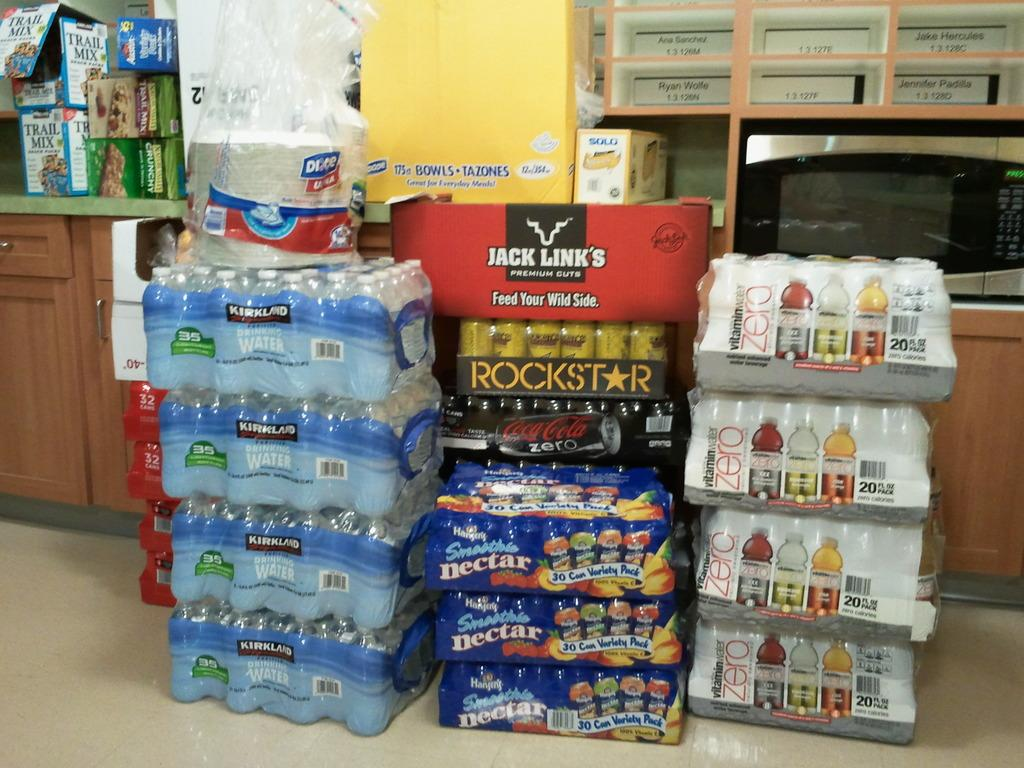<image>
Share a concise interpretation of the image provided. A lot of bottled water and witamin water zero stacked up 